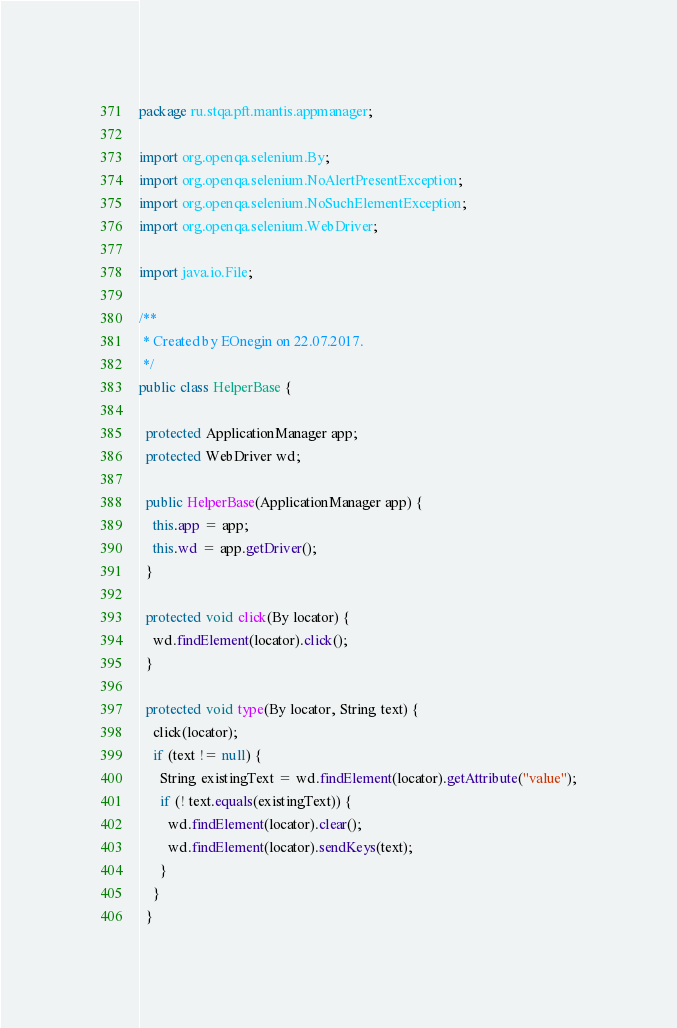<code> <loc_0><loc_0><loc_500><loc_500><_Java_>package ru.stqa.pft.mantis.appmanager;

import org.openqa.selenium.By;
import org.openqa.selenium.NoAlertPresentException;
import org.openqa.selenium.NoSuchElementException;
import org.openqa.selenium.WebDriver;

import java.io.File;

/**
 * Created by EOnegin on 22.07.2017.
 */
public class HelperBase {

  protected ApplicationManager app;
  protected WebDriver wd;

  public HelperBase(ApplicationManager app) {
    this.app = app;
    this.wd = app.getDriver();
  }

  protected void click(By locator) {
    wd.findElement(locator).click();
  }

  protected void type(By locator, String text) {
    click(locator);
    if (text != null) {
      String existingText = wd.findElement(locator).getAttribute("value");
      if (! text.equals(existingText)) {
        wd.findElement(locator).clear();
        wd.findElement(locator).sendKeys(text);
      }
    }
  }
</code> 